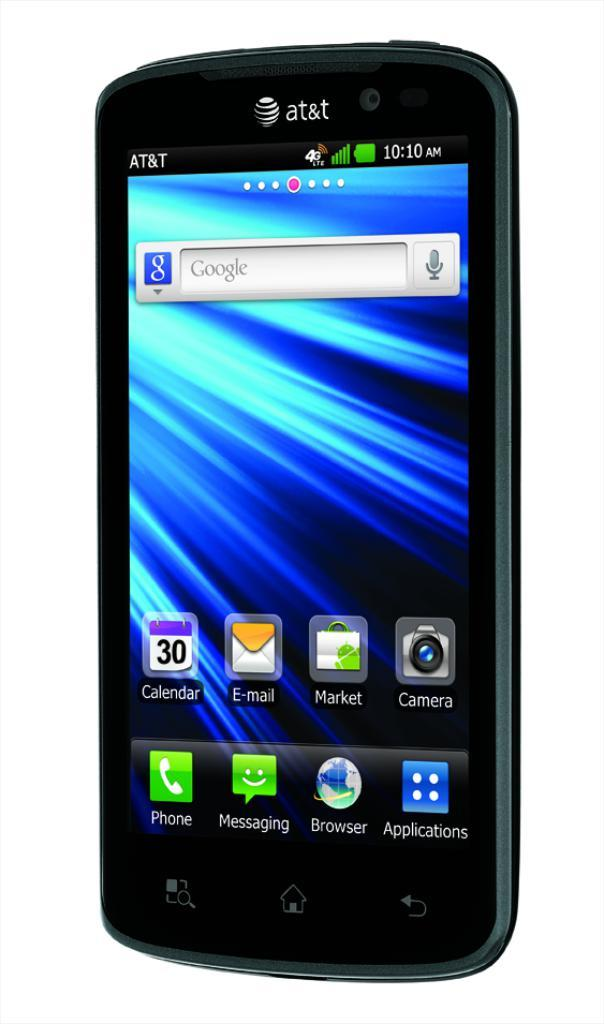<image>
Render a clear and concise summary of the photo. The black phone shown is by the brand At&t 